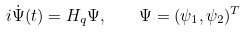Convert formula to latex. <formula><loc_0><loc_0><loc_500><loc_500>i \dot { \Psi } ( t ) = H _ { q } \Psi , \quad \Psi = ( \psi _ { 1 } , \psi _ { 2 } ) ^ { T }</formula> 